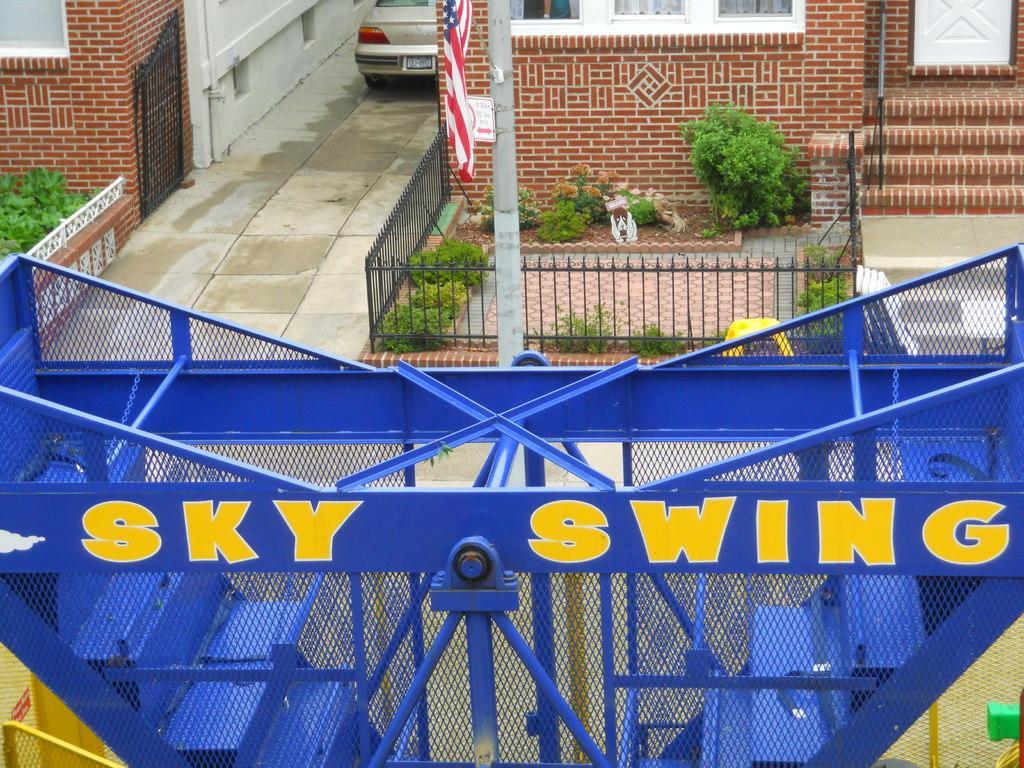Describe this image in one or two sentences. In the foreground of this image, there is an object and text written as ¨ SKY SWING¨. In the background, there is wall, gate, railing, planters, path, a vehicle, flag, pole, door and the stairs. 